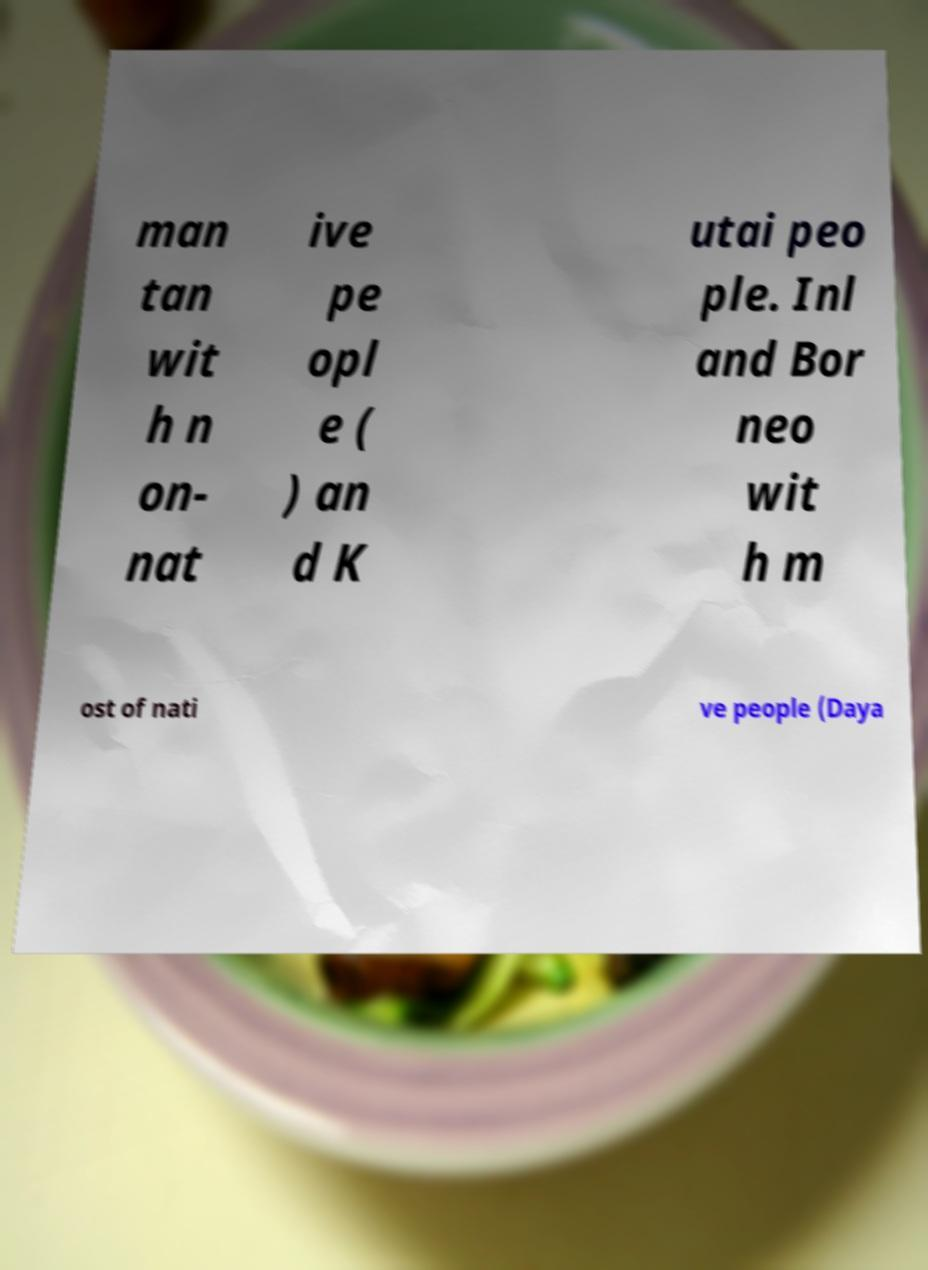Could you extract and type out the text from this image? man tan wit h n on- nat ive pe opl e ( ) an d K utai peo ple. Inl and Bor neo wit h m ost of nati ve people (Daya 